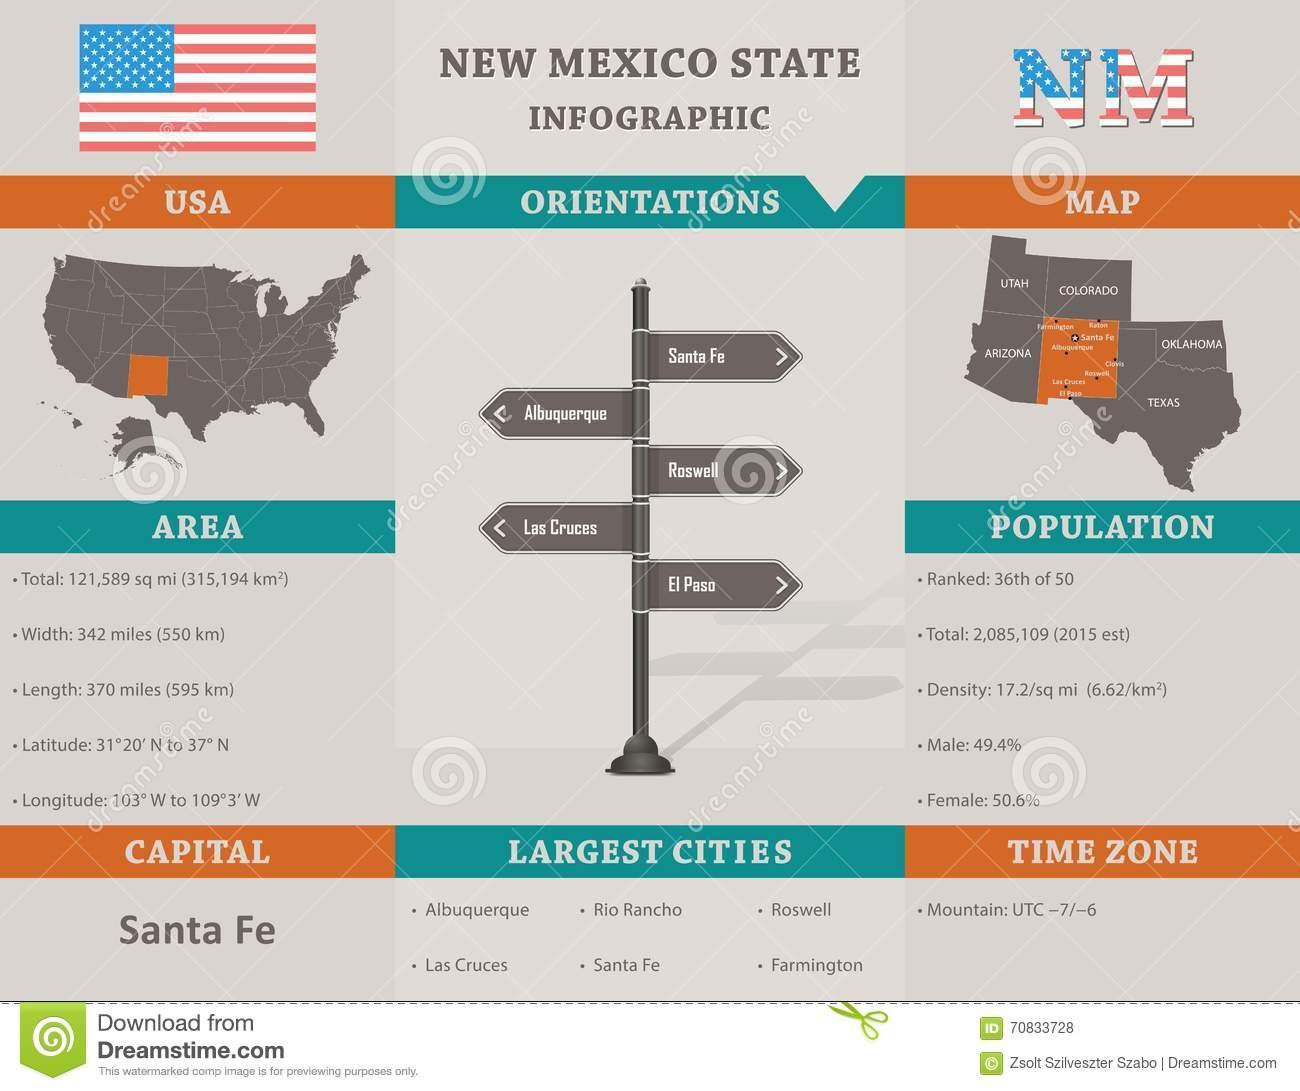List a handful of essential elements in this visual. There are five orientations for the state of New Mexico. In the state of New Mexico, there are six large urban areas. There is only one time zone in the state of New Mexico. 